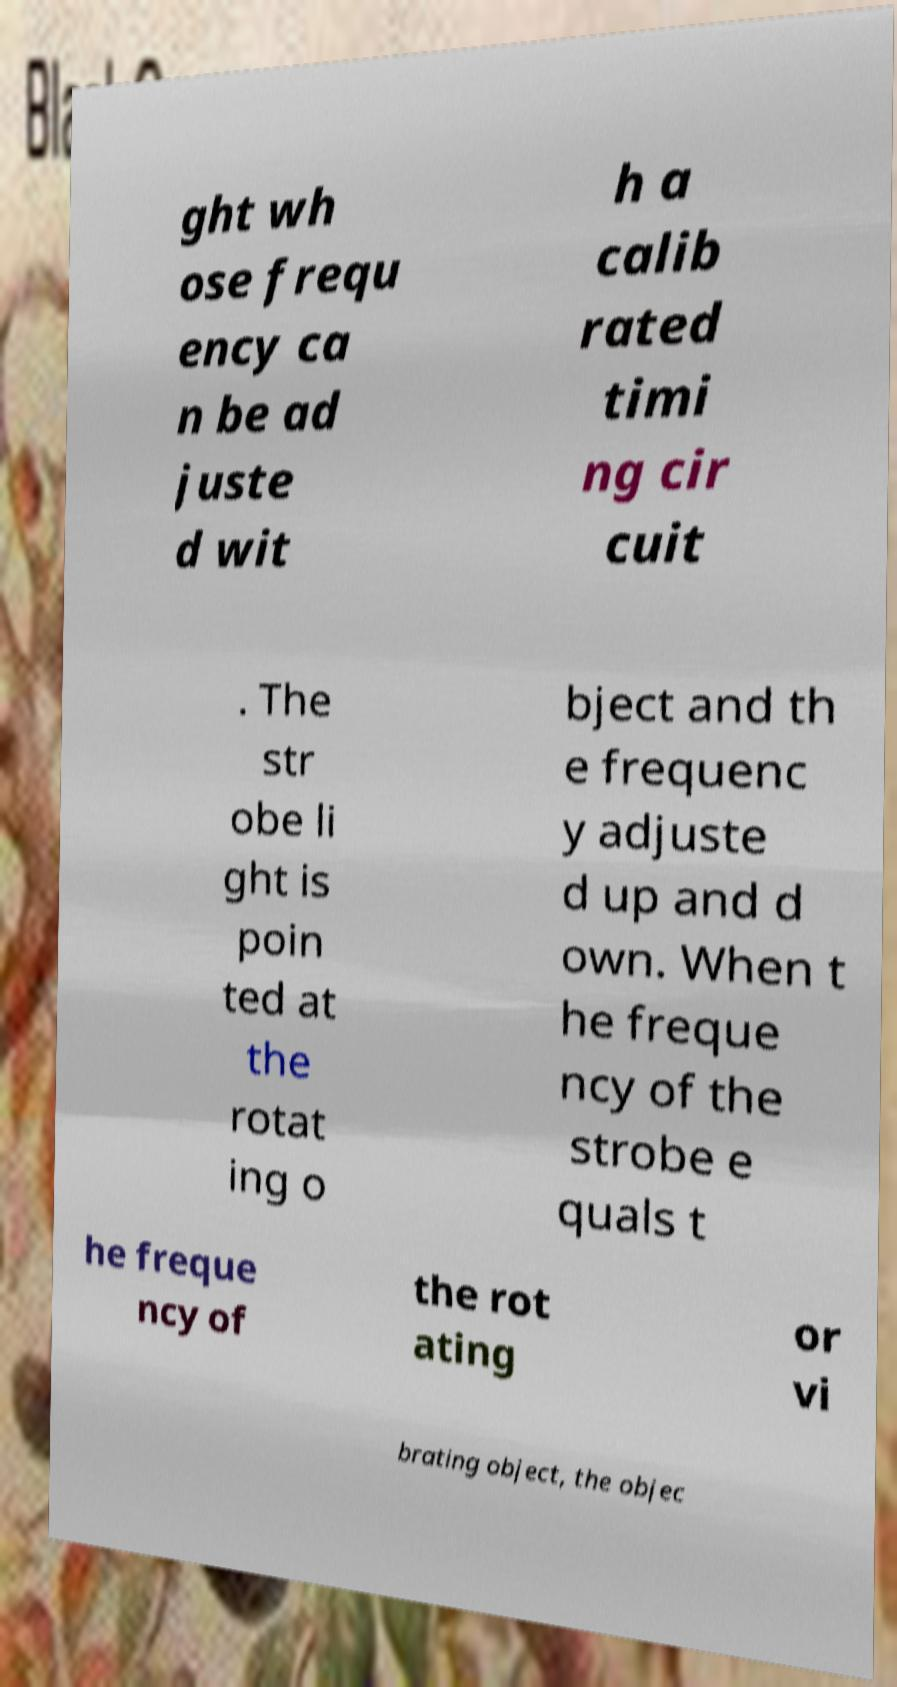I need the written content from this picture converted into text. Can you do that? ght wh ose frequ ency ca n be ad juste d wit h a calib rated timi ng cir cuit . The str obe li ght is poin ted at the rotat ing o bject and th e frequenc y adjuste d up and d own. When t he freque ncy of the strobe e quals t he freque ncy of the rot ating or vi brating object, the objec 